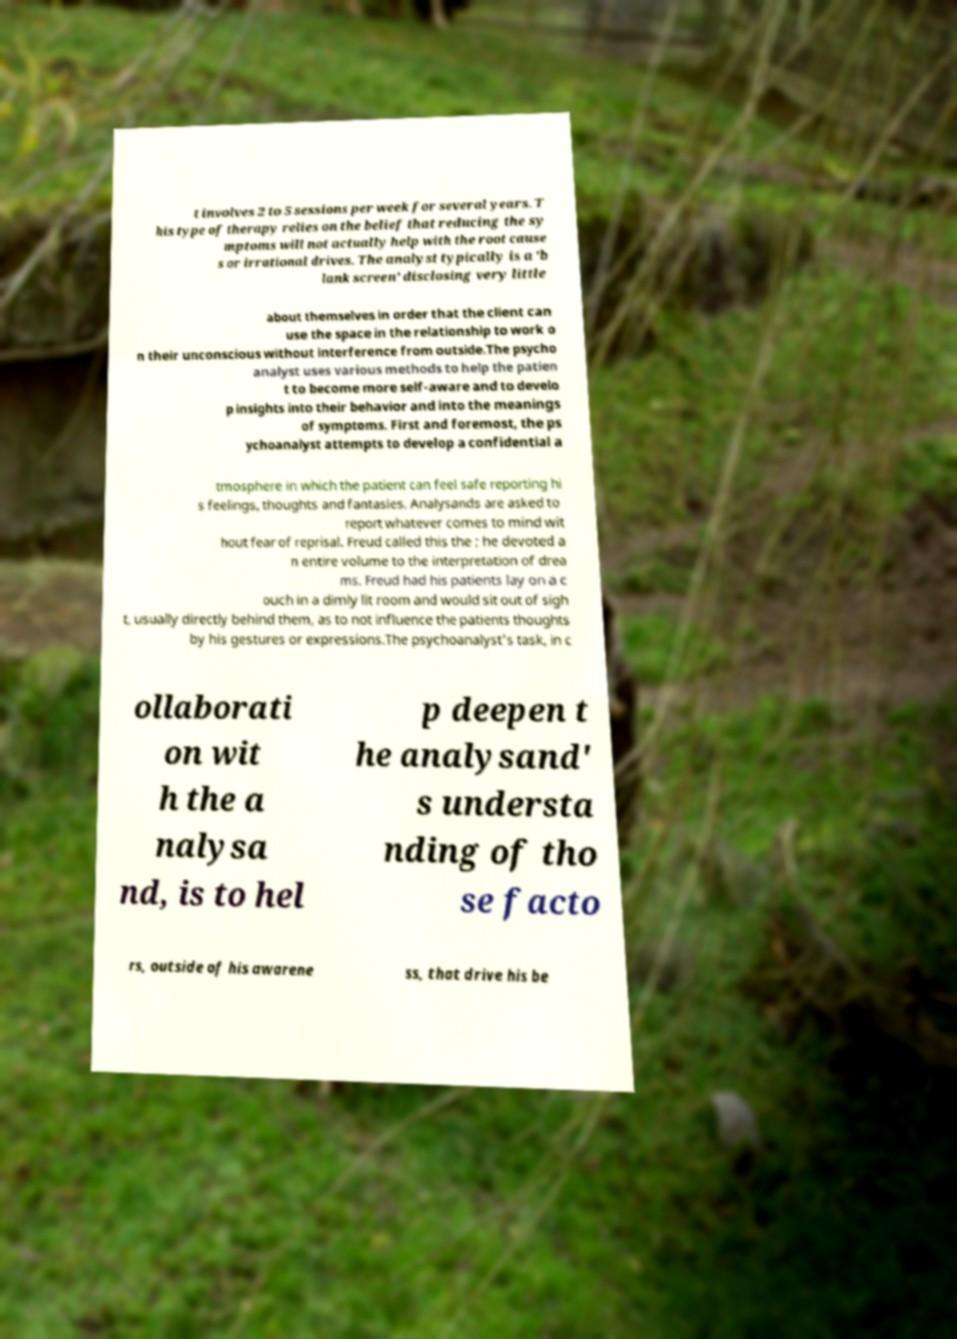Can you read and provide the text displayed in the image?This photo seems to have some interesting text. Can you extract and type it out for me? t involves 2 to 5 sessions per week for several years. T his type of therapy relies on the belief that reducing the sy mptoms will not actually help with the root cause s or irrational drives. The analyst typically is a 'b lank screen' disclosing very little about themselves in order that the client can use the space in the relationship to work o n their unconscious without interference from outside.The psycho analyst uses various methods to help the patien t to become more self-aware and to develo p insights into their behavior and into the meanings of symptoms. First and foremost, the ps ychoanalyst attempts to develop a confidential a tmosphere in which the patient can feel safe reporting hi s feelings, thoughts and fantasies. Analysands are asked to report whatever comes to mind wit hout fear of reprisal. Freud called this the ; he devoted a n entire volume to the interpretation of drea ms. Freud had his patients lay on a c ouch in a dimly lit room and would sit out of sigh t, usually directly behind them, as to not influence the patients thoughts by his gestures or expressions.The psychoanalyst's task, in c ollaborati on wit h the a nalysa nd, is to hel p deepen t he analysand' s understa nding of tho se facto rs, outside of his awarene ss, that drive his be 